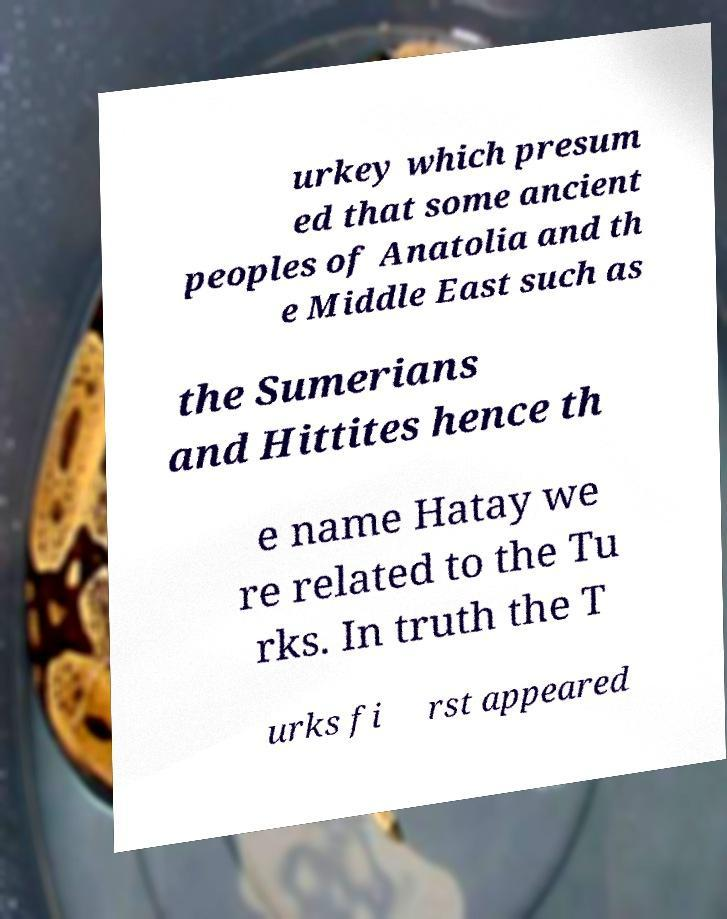I need the written content from this picture converted into text. Can you do that? urkey which presum ed that some ancient peoples of Anatolia and th e Middle East such as the Sumerians and Hittites hence th e name Hatay we re related to the Tu rks. In truth the T urks fi rst appeared 